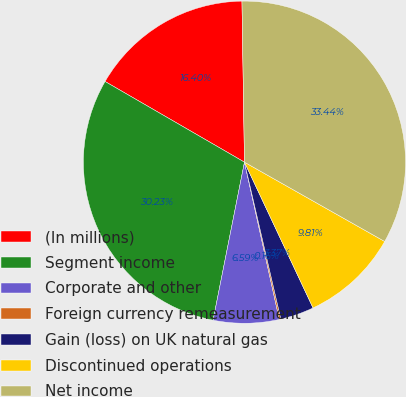Convert chart to OTSL. <chart><loc_0><loc_0><loc_500><loc_500><pie_chart><fcel>(In millions)<fcel>Segment income<fcel>Corporate and other<fcel>Foreign currency remeasurement<fcel>Gain (loss) on UK natural gas<fcel>Discontinued operations<fcel>Net income<nl><fcel>16.4%<fcel>30.23%<fcel>6.59%<fcel>0.16%<fcel>3.37%<fcel>9.81%<fcel>33.44%<nl></chart> 